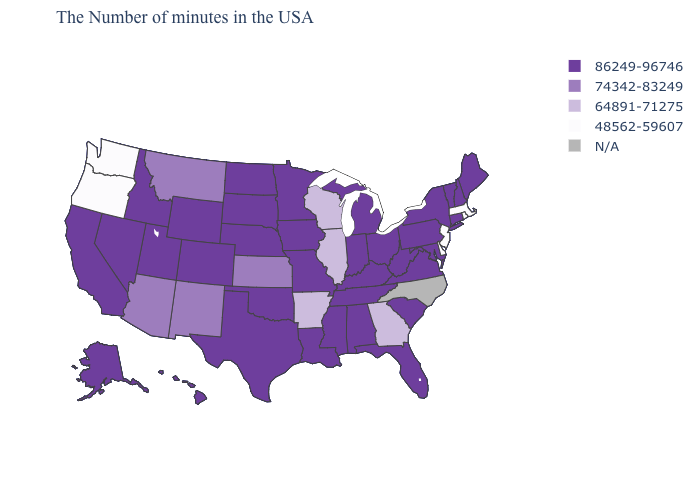How many symbols are there in the legend?
Short answer required. 5. Name the states that have a value in the range 64891-71275?
Short answer required. Georgia, Wisconsin, Illinois, Arkansas. What is the value of Louisiana?
Short answer required. 86249-96746. Among the states that border California , which have the highest value?
Concise answer only. Nevada. Name the states that have a value in the range 86249-96746?
Write a very short answer. Maine, New Hampshire, Vermont, Connecticut, New York, Maryland, Pennsylvania, Virginia, South Carolina, West Virginia, Ohio, Florida, Michigan, Kentucky, Indiana, Alabama, Tennessee, Mississippi, Louisiana, Missouri, Minnesota, Iowa, Nebraska, Oklahoma, Texas, South Dakota, North Dakota, Wyoming, Colorado, Utah, Idaho, Nevada, California, Alaska, Hawaii. Does the map have missing data?
Answer briefly. Yes. Does Rhode Island have the highest value in the Northeast?
Give a very brief answer. No. Name the states that have a value in the range 48562-59607?
Be succinct. Massachusetts, Rhode Island, New Jersey, Delaware, Washington, Oregon. Does Illinois have the lowest value in the MidWest?
Concise answer only. Yes. What is the value of Rhode Island?
Concise answer only. 48562-59607. What is the value of Delaware?
Give a very brief answer. 48562-59607. Does the first symbol in the legend represent the smallest category?
Write a very short answer. No. Name the states that have a value in the range 74342-83249?
Concise answer only. Kansas, New Mexico, Montana, Arizona. 